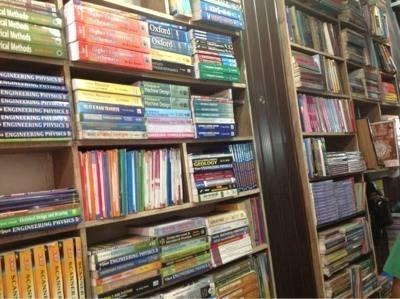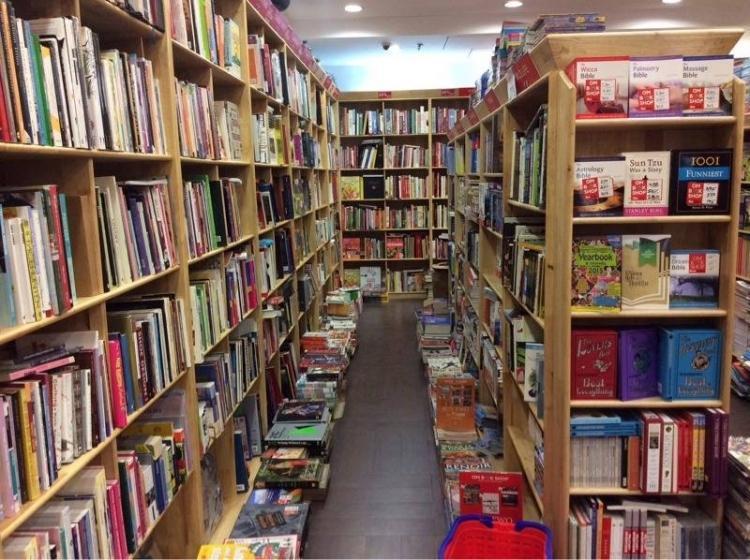The first image is the image on the left, the second image is the image on the right. Given the left and right images, does the statement "One image shows book-type items displayed vertically on shelves viewed head-on, and neither image shows people standing in a store." hold true? Answer yes or no. No. 